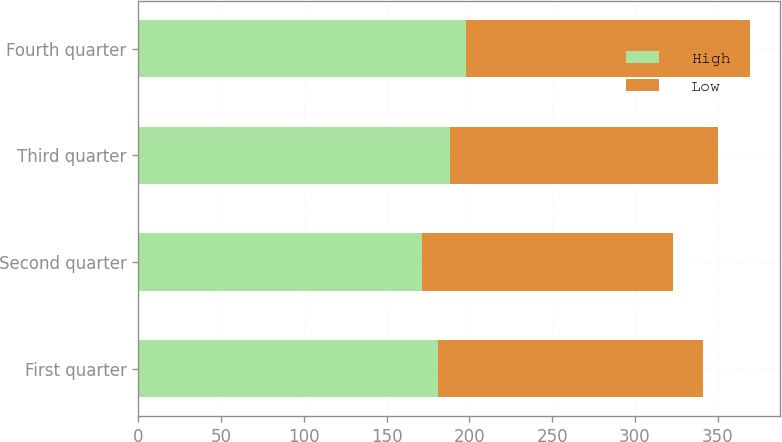Convert chart. <chart><loc_0><loc_0><loc_500><loc_500><stacked_bar_chart><ecel><fcel>First quarter<fcel>Second quarter<fcel>Third quarter<fcel>Fourth quarter<nl><fcel>High<fcel>181.13<fcel>171.08<fcel>188.58<fcel>198.06<nl><fcel>Low<fcel>159.77<fcel>151.65<fcel>161.53<fcel>171.26<nl></chart> 